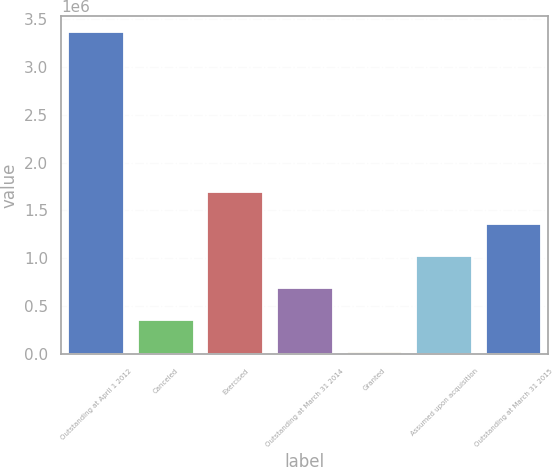Convert chart. <chart><loc_0><loc_0><loc_500><loc_500><bar_chart><fcel>Outstanding at April 1 2012<fcel>Canceled<fcel>Exercised<fcel>Outstanding at March 31 2014<fcel>Granted<fcel>Assumed upon acquisition<fcel>Outstanding at March 31 2015<nl><fcel>3.361e+06<fcel>360988<fcel>1.69433e+06<fcel>694323<fcel>27654<fcel>1.02766e+06<fcel>1.36099e+06<nl></chart> 